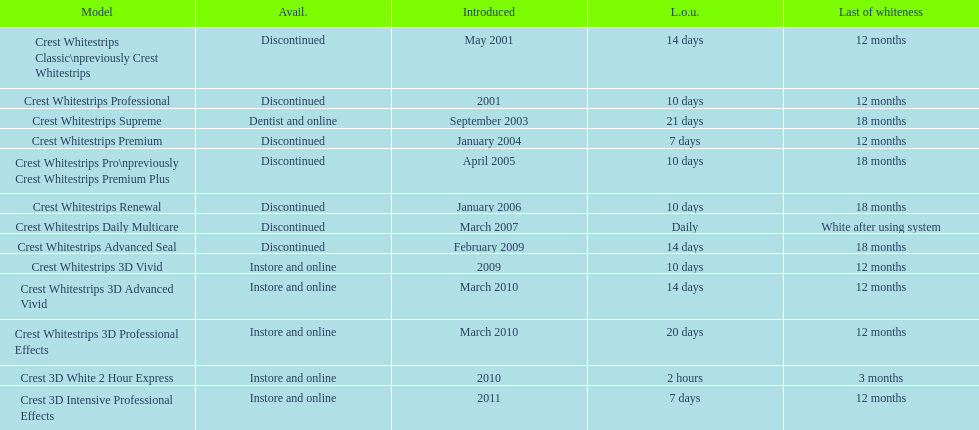Which model features the highest 'time of use' to 'end of whiteness' ratio? Crest Whitestrips Supreme. 